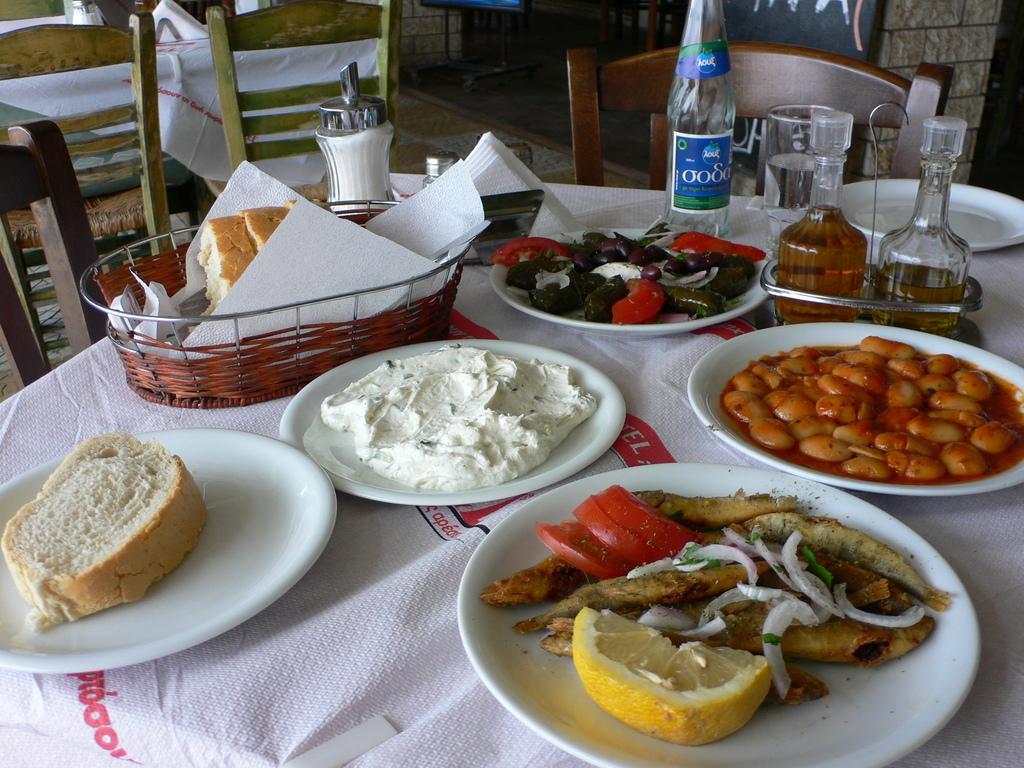Could you give a brief overview of what you see in this image? In the image we can see chair and a table, on the table we can even see plate, bottle, tissue and food. There is a lemon and tomato slice in the plate. 